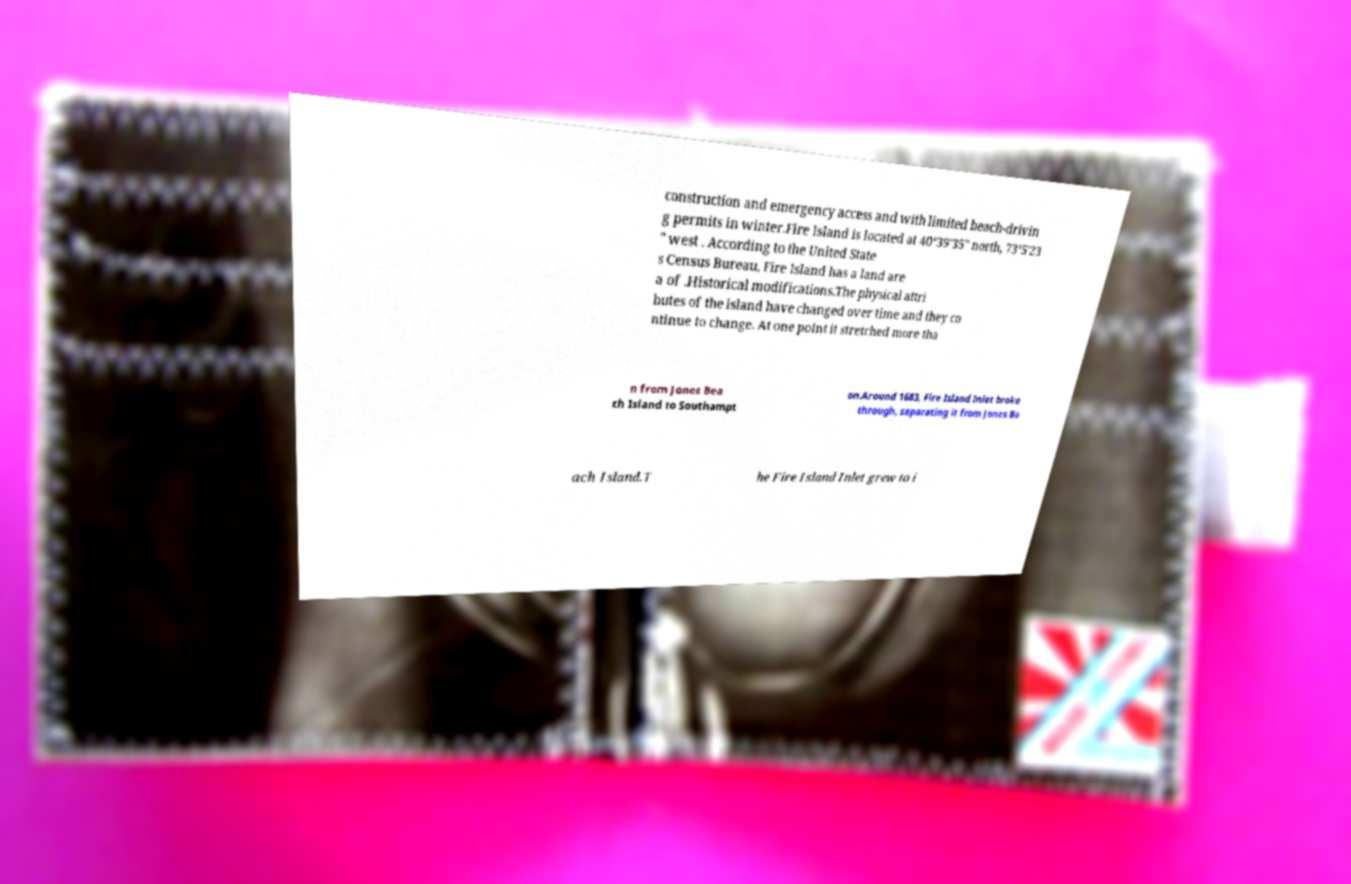Please read and relay the text visible in this image. What does it say? construction and emergency access and with limited beach-drivin g permits in winter.Fire Island is located at 40°39′35″ north, 73°5′23 ″ west . According to the United State s Census Bureau, Fire Island has a land are a of .Historical modifications.The physical attri butes of the island have changed over time and they co ntinue to change. At one point it stretched more tha n from Jones Bea ch Island to Southampt on.Around 1683, Fire Island Inlet broke through, separating it from Jones Be ach Island.T he Fire Island Inlet grew to i 